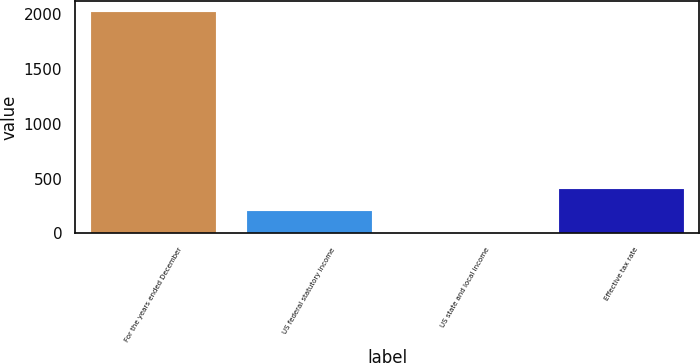<chart> <loc_0><loc_0><loc_500><loc_500><bar_chart><fcel>For the years ended December<fcel>US federal statutory income<fcel>US state and local income<fcel>Effective tax rate<nl><fcel>2015<fcel>203.57<fcel>2.3<fcel>404.84<nl></chart> 